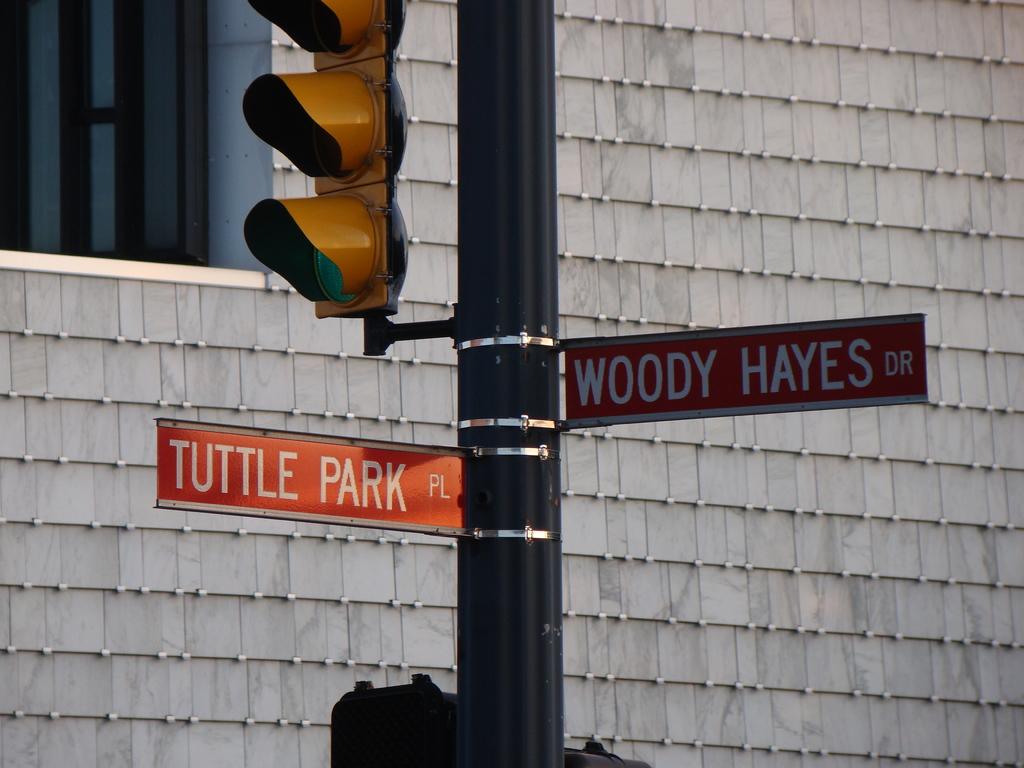What are the cross streets?
Provide a succinct answer. Tuttle park pl and woody hayes dr. What is the name of the park?
Provide a succinct answer. Tuttle. 